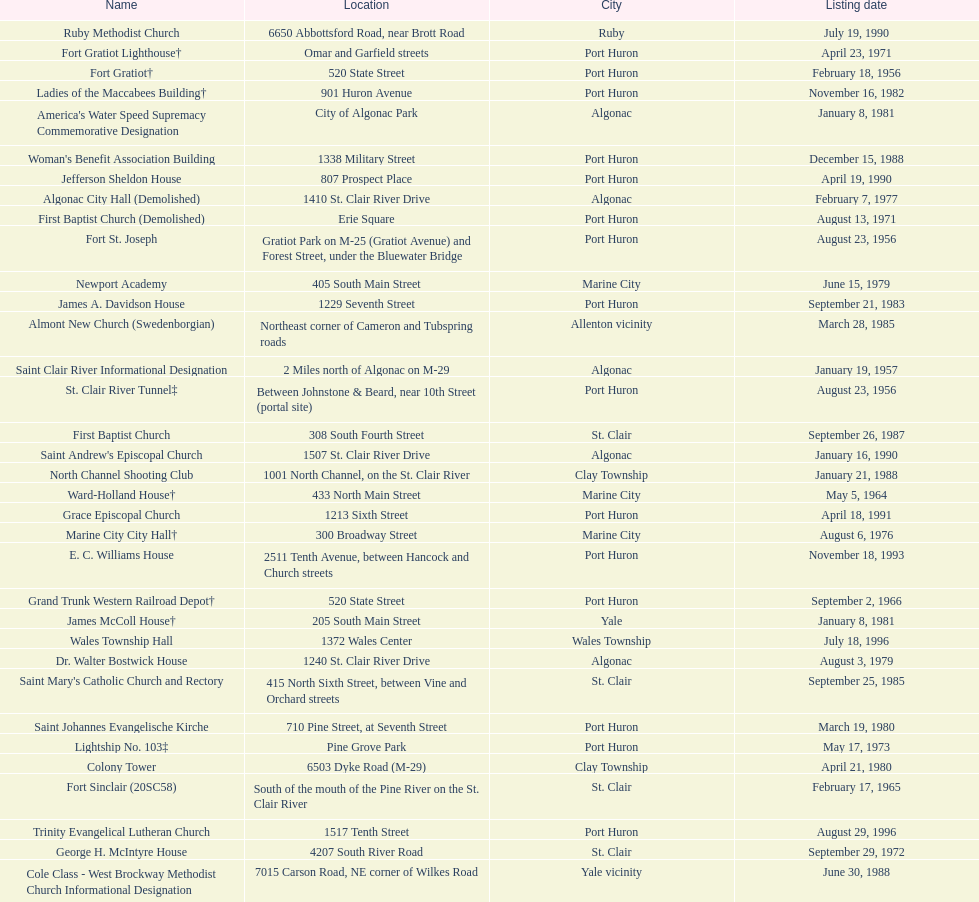How many names do not have images next to them? 41. Could you parse the entire table as a dict? {'header': ['Name', 'Location', 'City', 'Listing date'], 'rows': [['Ruby Methodist Church', '6650 Abbottsford Road, near Brott Road', 'Ruby', 'July 19, 1990'], ['Fort Gratiot Lighthouse†', 'Omar and Garfield streets', 'Port Huron', 'April 23, 1971'], ['Fort Gratiot†', '520 State Street', 'Port Huron', 'February 18, 1956'], ['Ladies of the Maccabees Building†', '901 Huron Avenue', 'Port Huron', 'November 16, 1982'], ["America's Water Speed Supremacy Commemorative Designation", 'City of Algonac Park', 'Algonac', 'January 8, 1981'], ["Woman's Benefit Association Building", '1338 Military Street', 'Port Huron', 'December 15, 1988'], ['Jefferson Sheldon House', '807 Prospect Place', 'Port Huron', 'April 19, 1990'], ['Algonac City Hall (Demolished)', '1410 St. Clair River Drive', 'Algonac', 'February 7, 1977'], ['First Baptist Church (Demolished)', 'Erie Square', 'Port Huron', 'August 13, 1971'], ['Fort St. Joseph', 'Gratiot Park on M-25 (Gratiot Avenue) and Forest Street, under the Bluewater Bridge', 'Port Huron', 'August 23, 1956'], ['Newport Academy', '405 South Main Street', 'Marine City', 'June 15, 1979'], ['James A. Davidson House', '1229 Seventh Street', 'Port Huron', 'September 21, 1983'], ['Almont New Church (Swedenborgian)', 'Northeast corner of Cameron and Tubspring roads', 'Allenton vicinity', 'March 28, 1985'], ['Saint Clair River Informational Designation', '2 Miles north of Algonac on M-29', 'Algonac', 'January 19, 1957'], ['St. Clair River Tunnel‡', 'Between Johnstone & Beard, near 10th Street (portal site)', 'Port Huron', 'August 23, 1956'], ['First Baptist Church', '308 South Fourth Street', 'St. Clair', 'September 26, 1987'], ["Saint Andrew's Episcopal Church", '1507 St. Clair River Drive', 'Algonac', 'January 16, 1990'], ['North Channel Shooting Club', '1001 North Channel, on the St. Clair River', 'Clay Township', 'January 21, 1988'], ['Ward-Holland House†', '433 North Main Street', 'Marine City', 'May 5, 1964'], ['Grace Episcopal Church', '1213 Sixth Street', 'Port Huron', 'April 18, 1991'], ['Marine City City Hall†', '300 Broadway Street', 'Marine City', 'August 6, 1976'], ['E. C. Williams House', '2511 Tenth Avenue, between Hancock and Church streets', 'Port Huron', 'November 18, 1993'], ['Grand Trunk Western Railroad Depot†', '520 State Street', 'Port Huron', 'September 2, 1966'], ['James McColl House†', '205 South Main Street', 'Yale', 'January 8, 1981'], ['Wales Township Hall', '1372 Wales Center', 'Wales Township', 'July 18, 1996'], ['Dr. Walter Bostwick House', '1240 St. Clair River Drive', 'Algonac', 'August 3, 1979'], ["Saint Mary's Catholic Church and Rectory", '415 North Sixth Street, between Vine and Orchard streets', 'St. Clair', 'September 25, 1985'], ['Saint Johannes Evangelische Kirche', '710 Pine Street, at Seventh Street', 'Port Huron', 'March 19, 1980'], ['Lightship No. 103‡', 'Pine Grove Park', 'Port Huron', 'May 17, 1973'], ['Colony Tower', '6503 Dyke Road (M-29)', 'Clay Township', 'April 21, 1980'], ['Fort Sinclair (20SC58)', 'South of the mouth of the Pine River on the St. Clair River', 'St. Clair', 'February 17, 1965'], ['Trinity Evangelical Lutheran Church', '1517 Tenth Street', 'Port Huron', 'August 29, 1996'], ['George H. McIntyre House', '4207 South River Road', 'St. Clair', 'September 29, 1972'], ['Cole Class - West Brockway Methodist Church Informational Designation', '7015 Carson Road, NE corner of Wilkes Road', 'Yale vicinity', 'June 30, 1988'], ['Harrington Hotel†', '1026 Military, between Pine and Wall Streets', 'Port Huron', 'November 16, 1981'], ['Wilbur F. Davidson House†', '1707 Military Street', 'Port Huron', 'May 17, 1973'], ['Catholic Pointe', '618 South Water Street, SE corner of Bridge Street', 'Marine City', 'August 12, 1977'], ['C. H. Wills & Company', 'Chrysler Plant, 840 Huron Avenue', 'Marysville', 'June 23, 1983'], ['East China Fractional District No. 2 School', '696 Meisner Road', 'Marine City', 'July 18, 1991'], ['Congregational Church', '300 Adams St', 'St. Clair', 'August 3, 1979'], ['Harsen Home', '2006 Golf Course Road', 'Harsens Island', 'February 7, 1977'], ['Graziadei-Casello Building', '307 Huron Avenue', 'Port Huron', 'November 16, 1995'], ['Gratiot Park United Methodist Church', '2503 Cherry Street', 'Port Huron', 'March 10, 1988'], ['Port Huron High School', '323 Erie Street', 'Port Huron', 'December 15, 1988'], ['Saint Clair Inn†', '500 Riverside', 'St. Clair', 'October 20, 1994']]} 